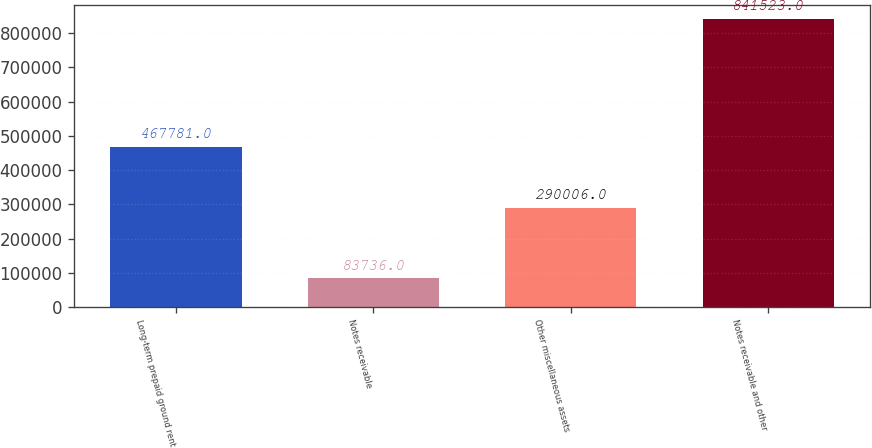<chart> <loc_0><loc_0><loc_500><loc_500><bar_chart><fcel>Long-term prepaid ground rent<fcel>Notes receivable<fcel>Other miscellaneous assets<fcel>Notes receivable and other<nl><fcel>467781<fcel>83736<fcel>290006<fcel>841523<nl></chart> 